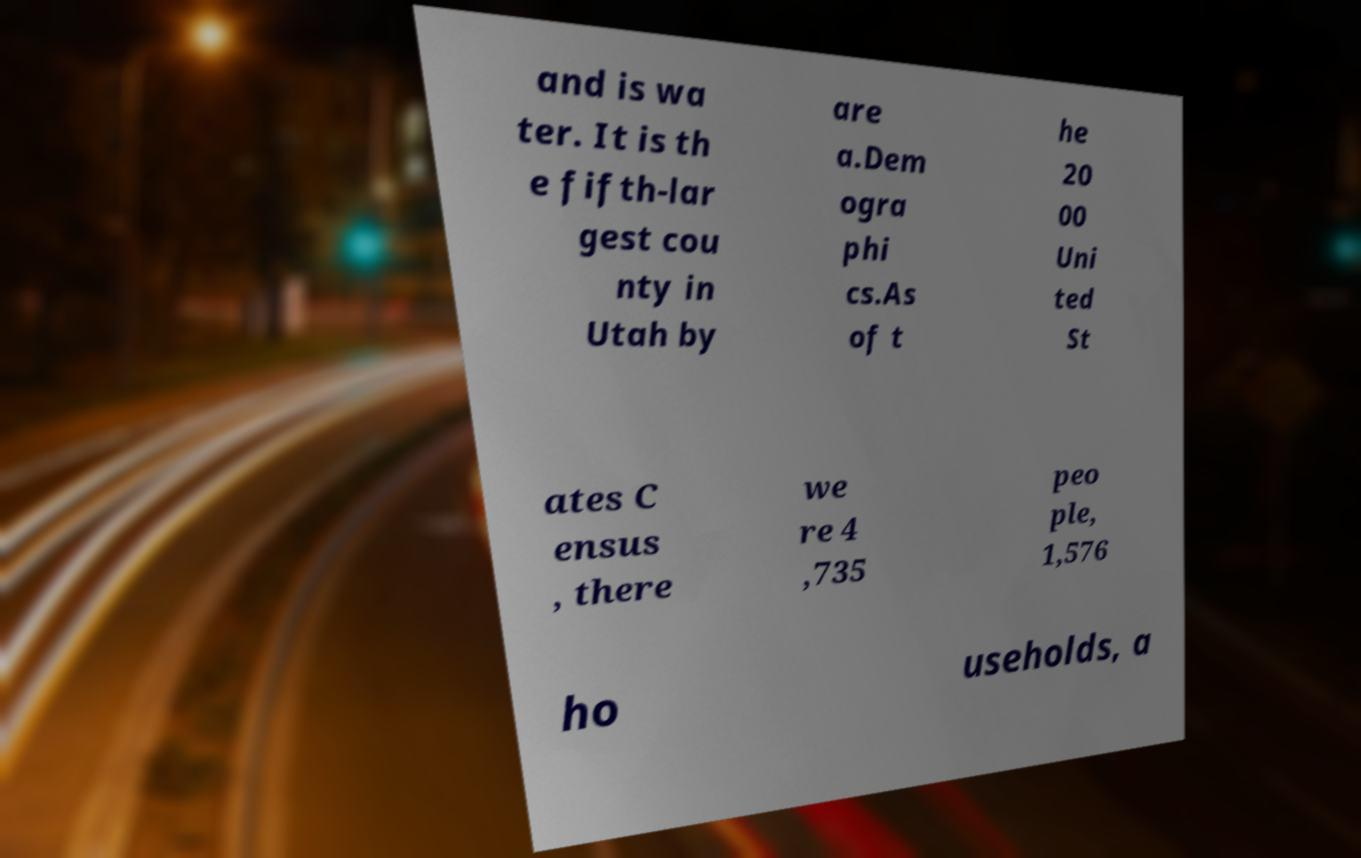I need the written content from this picture converted into text. Can you do that? and is wa ter. It is th e fifth-lar gest cou nty in Utah by are a.Dem ogra phi cs.As of t he 20 00 Uni ted St ates C ensus , there we re 4 ,735 peo ple, 1,576 ho useholds, a 